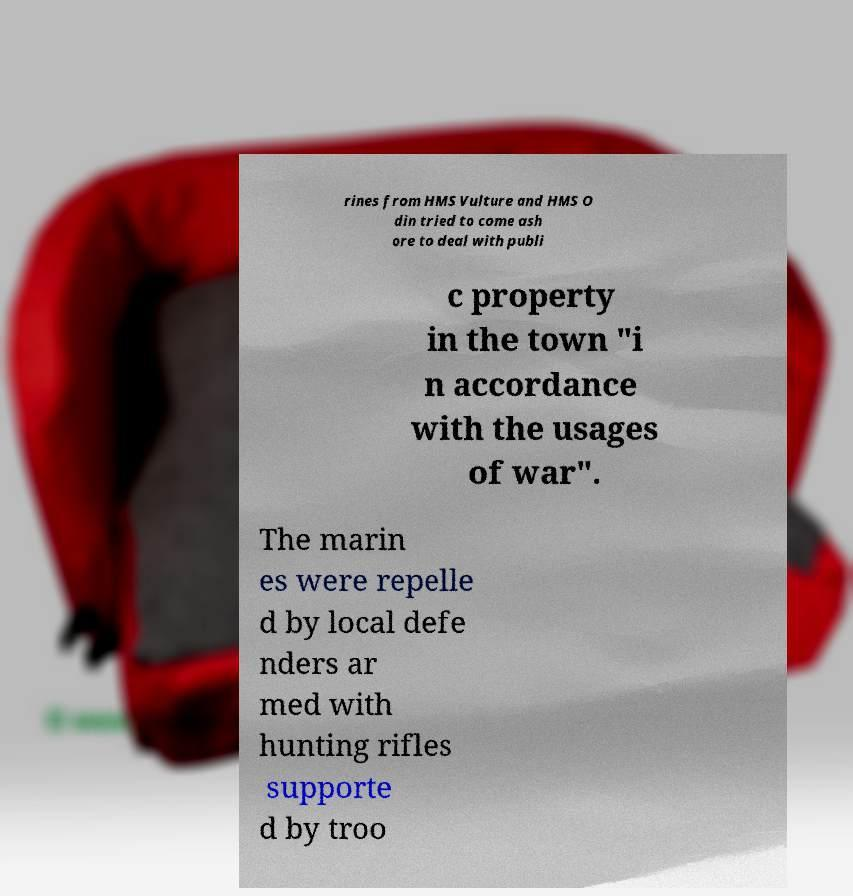Could you extract and type out the text from this image? rines from HMS Vulture and HMS O din tried to come ash ore to deal with publi c property in the town "i n accordance with the usages of war". The marin es were repelle d by local defe nders ar med with hunting rifles supporte d by troo 